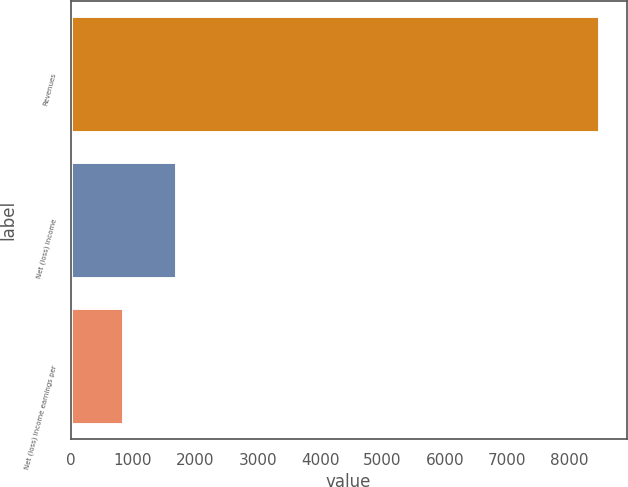Convert chart. <chart><loc_0><loc_0><loc_500><loc_500><bar_chart><fcel>Revenues<fcel>Net (loss) income<fcel>Net (loss) income earnings per<nl><fcel>8490<fcel>1698.58<fcel>849.65<nl></chart> 